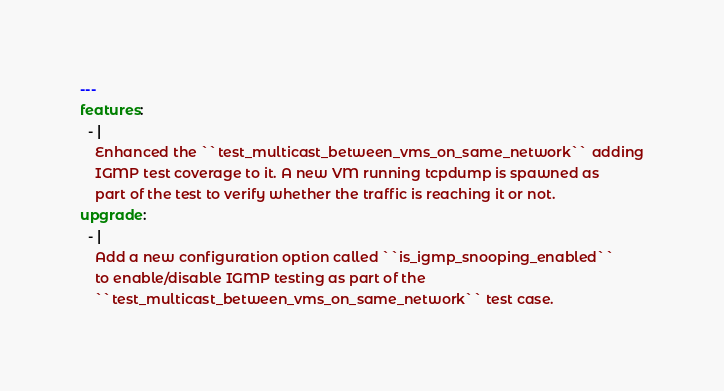<code> <loc_0><loc_0><loc_500><loc_500><_YAML_>---
features:
  - |
    Enhanced the ``test_multicast_between_vms_on_same_network`` adding
    IGMP test coverage to it. A new VM running tcpdump is spawned as
    part of the test to verify whether the traffic is reaching it or not.
upgrade:
  - |
    Add a new configuration option called ``is_igmp_snooping_enabled``
    to enable/disable IGMP testing as part of the
    ``test_multicast_between_vms_on_same_network`` test case.
</code> 